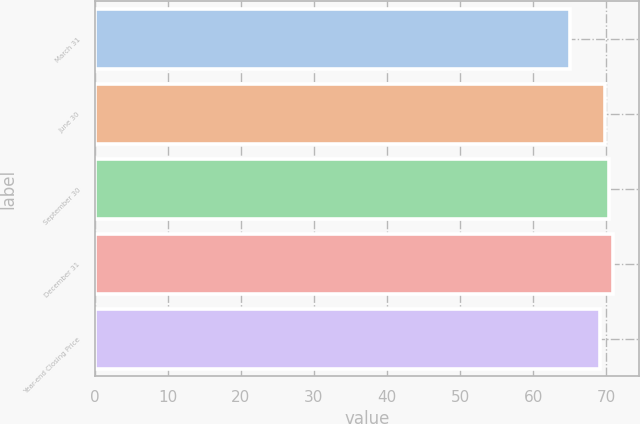<chart> <loc_0><loc_0><loc_500><loc_500><bar_chart><fcel>March 31<fcel>June 30<fcel>September 30<fcel>December 31<fcel>Year-end Closing Price<nl><fcel>65.08<fcel>69.78<fcel>70.37<fcel>71<fcel>69.19<nl></chart> 